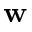Convert formula to latex. <formula><loc_0><loc_0><loc_500><loc_500>w</formula> 